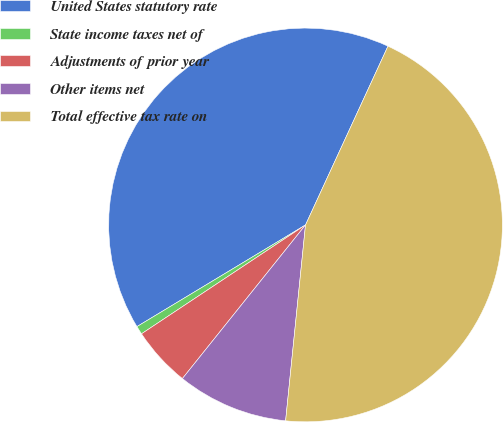Convert chart. <chart><loc_0><loc_0><loc_500><loc_500><pie_chart><fcel>United States statutory rate<fcel>State income taxes net of<fcel>Adjustments of prior year<fcel>Other items net<fcel>Total effective tax rate on<nl><fcel>40.51%<fcel>0.69%<fcel>4.92%<fcel>9.14%<fcel>44.73%<nl></chart> 